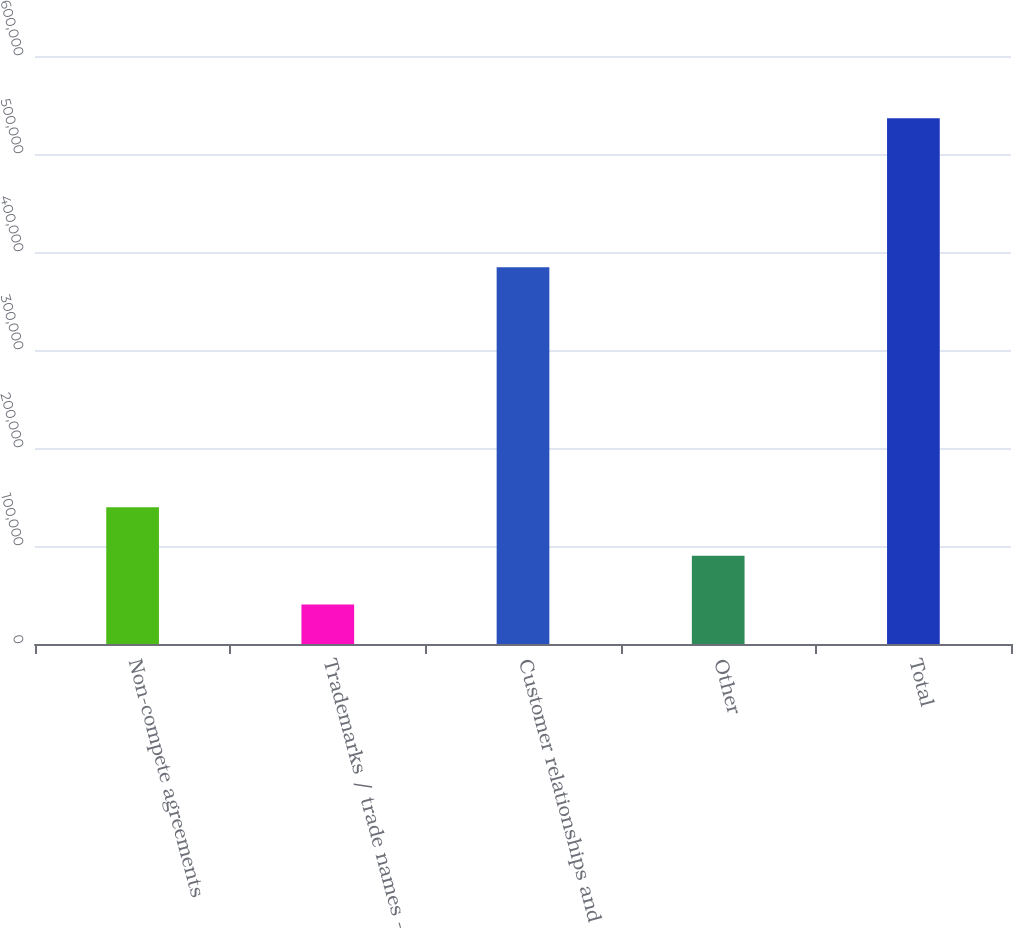<chart> <loc_0><loc_0><loc_500><loc_500><bar_chart><fcel>Non-compete agreements<fcel>Trademarks / trade names -<fcel>Customer relationships and<fcel>Other<fcel>Total<nl><fcel>139554<fcel>40346<fcel>384365<fcel>89950.2<fcel>536388<nl></chart> 